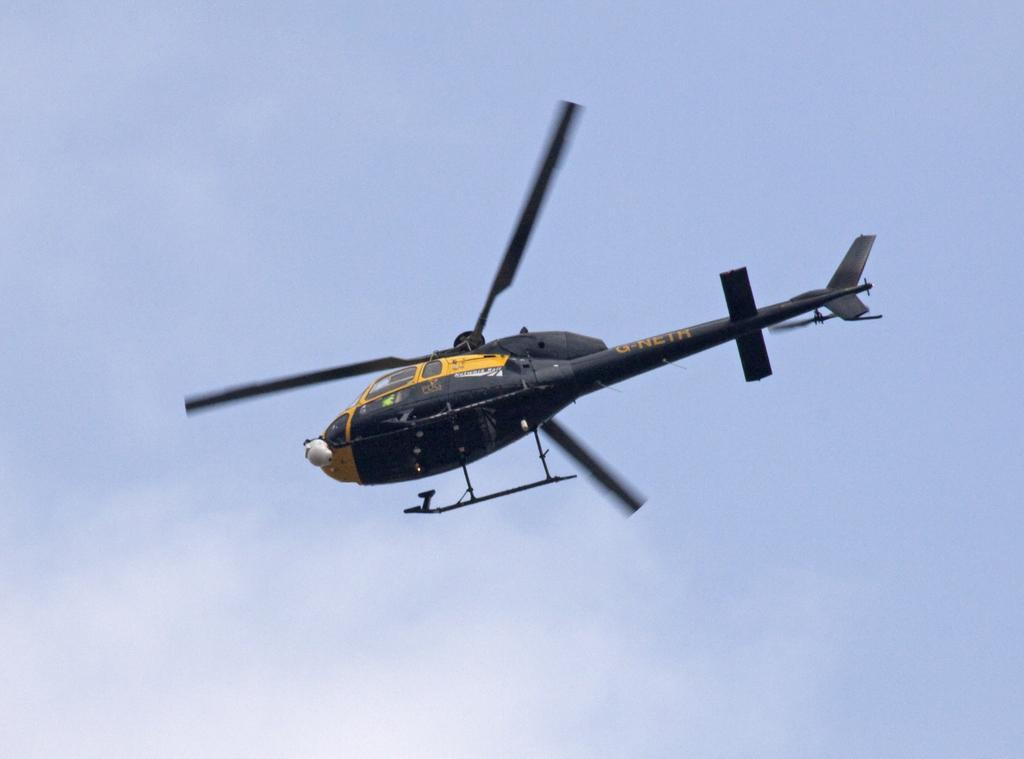What is the main subject of the image? The main subject of the image is an aircraft. What can be seen in the background of the image? The sky is visible in the background of the image. How many flowers are growing near the aircraft in the image? There are no flowers present in the image; it features an aircraft and the sky. What type of snail can be seen crawling on the aircraft in the image? There is no snail present on the aircraft in the image. 